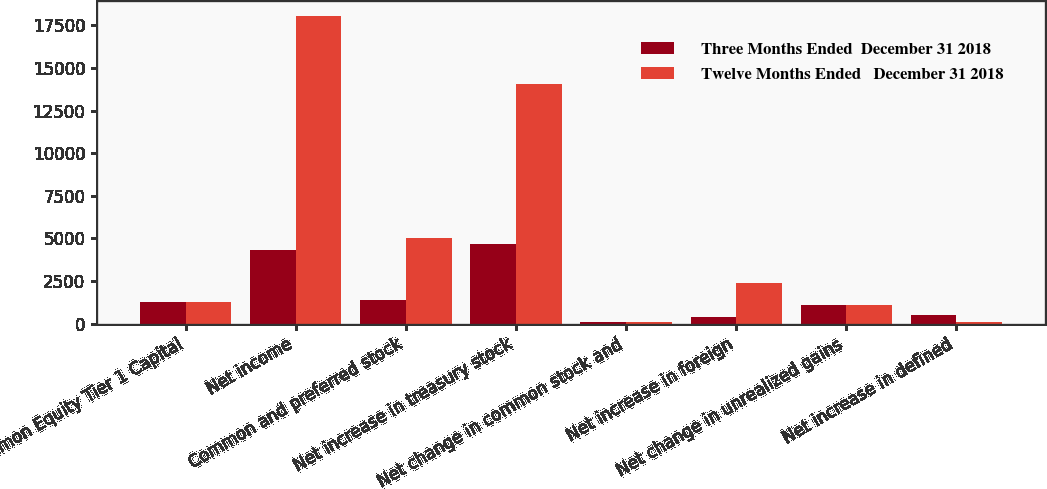Convert chart to OTSL. <chart><loc_0><loc_0><loc_500><loc_500><stacked_bar_chart><ecel><fcel>Common Equity Tier 1 Capital<fcel>Net income<fcel>Common and preferred stock<fcel>Net increase in treasury stock<fcel>Net change in common stock and<fcel>Net increase in foreign<fcel>Net change in unrealized gains<fcel>Net increase in defined<nl><fcel>Three Months Ended  December 31 2018<fcel>1247<fcel>4313<fcel>1402<fcel>4692<fcel>81<fcel>394<fcel>1072<fcel>489<nl><fcel>Twelve Months Ended   December 31 2018<fcel>1247<fcel>18045<fcel>5039<fcel>14061<fcel>102<fcel>2362<fcel>1092<fcel>74<nl></chart> 